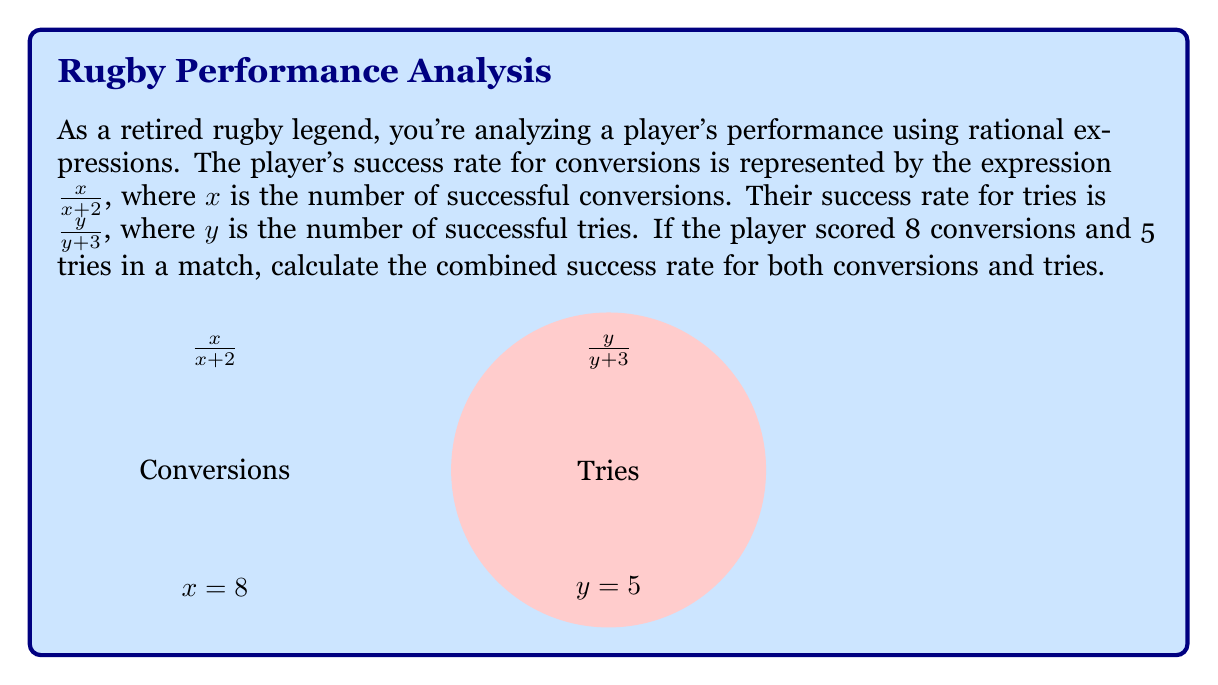What is the answer to this math problem? Let's approach this step-by-step:

1) First, we need to calculate the success rate for conversions:
   $x = 8$, so the success rate is $\frac{8}{8+2} = \frac{8}{10} = 0.8$ or 80%

2) Next, we calculate the success rate for tries:
   $y = 5$, so the success rate is $\frac{5}{5+3} = \frac{5}{8} = 0.625$ or 62.5%

3) To find the combined success rate, we need to add these fractions. However, we can't simply add the percentages. We need to consider the total number of attempts for each.

4) Total conversion attempts: $8 + 2 = 10$
   Total try attempts: $5 + 3 = 8$

5) Now, we can set up a new rational expression for the combined success rate:
   $$\frac{\text{Total Successes}}{\text{Total Attempts}} = \frac{8 + 5}{10 + 8} = \frac{13}{18}$$

6) To get the final percentage, we divide:
   $\frac{13}{18} \approx 0.7222$ or approximately 72.22%
Answer: $\frac{13}{18}$ or approximately 72.22% 